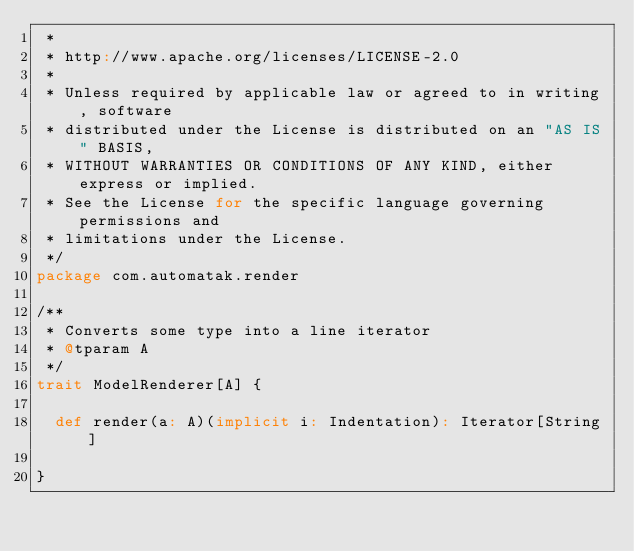Convert code to text. <code><loc_0><loc_0><loc_500><loc_500><_Scala_> *
 * http://www.apache.org/licenses/LICENSE-2.0
 *
 * Unless required by applicable law or agreed to in writing, software
 * distributed under the License is distributed on an "AS IS" BASIS,
 * WITHOUT WARRANTIES OR CONDITIONS OF ANY KIND, either express or implied.
 * See the License for the specific language governing permissions and
 * limitations under the License.
 */
package com.automatak.render

/**
 * Converts some type into a line iterator
 * @tparam A
 */
trait ModelRenderer[A] {

  def render(a: A)(implicit i: Indentation): Iterator[String]

}
</code> 